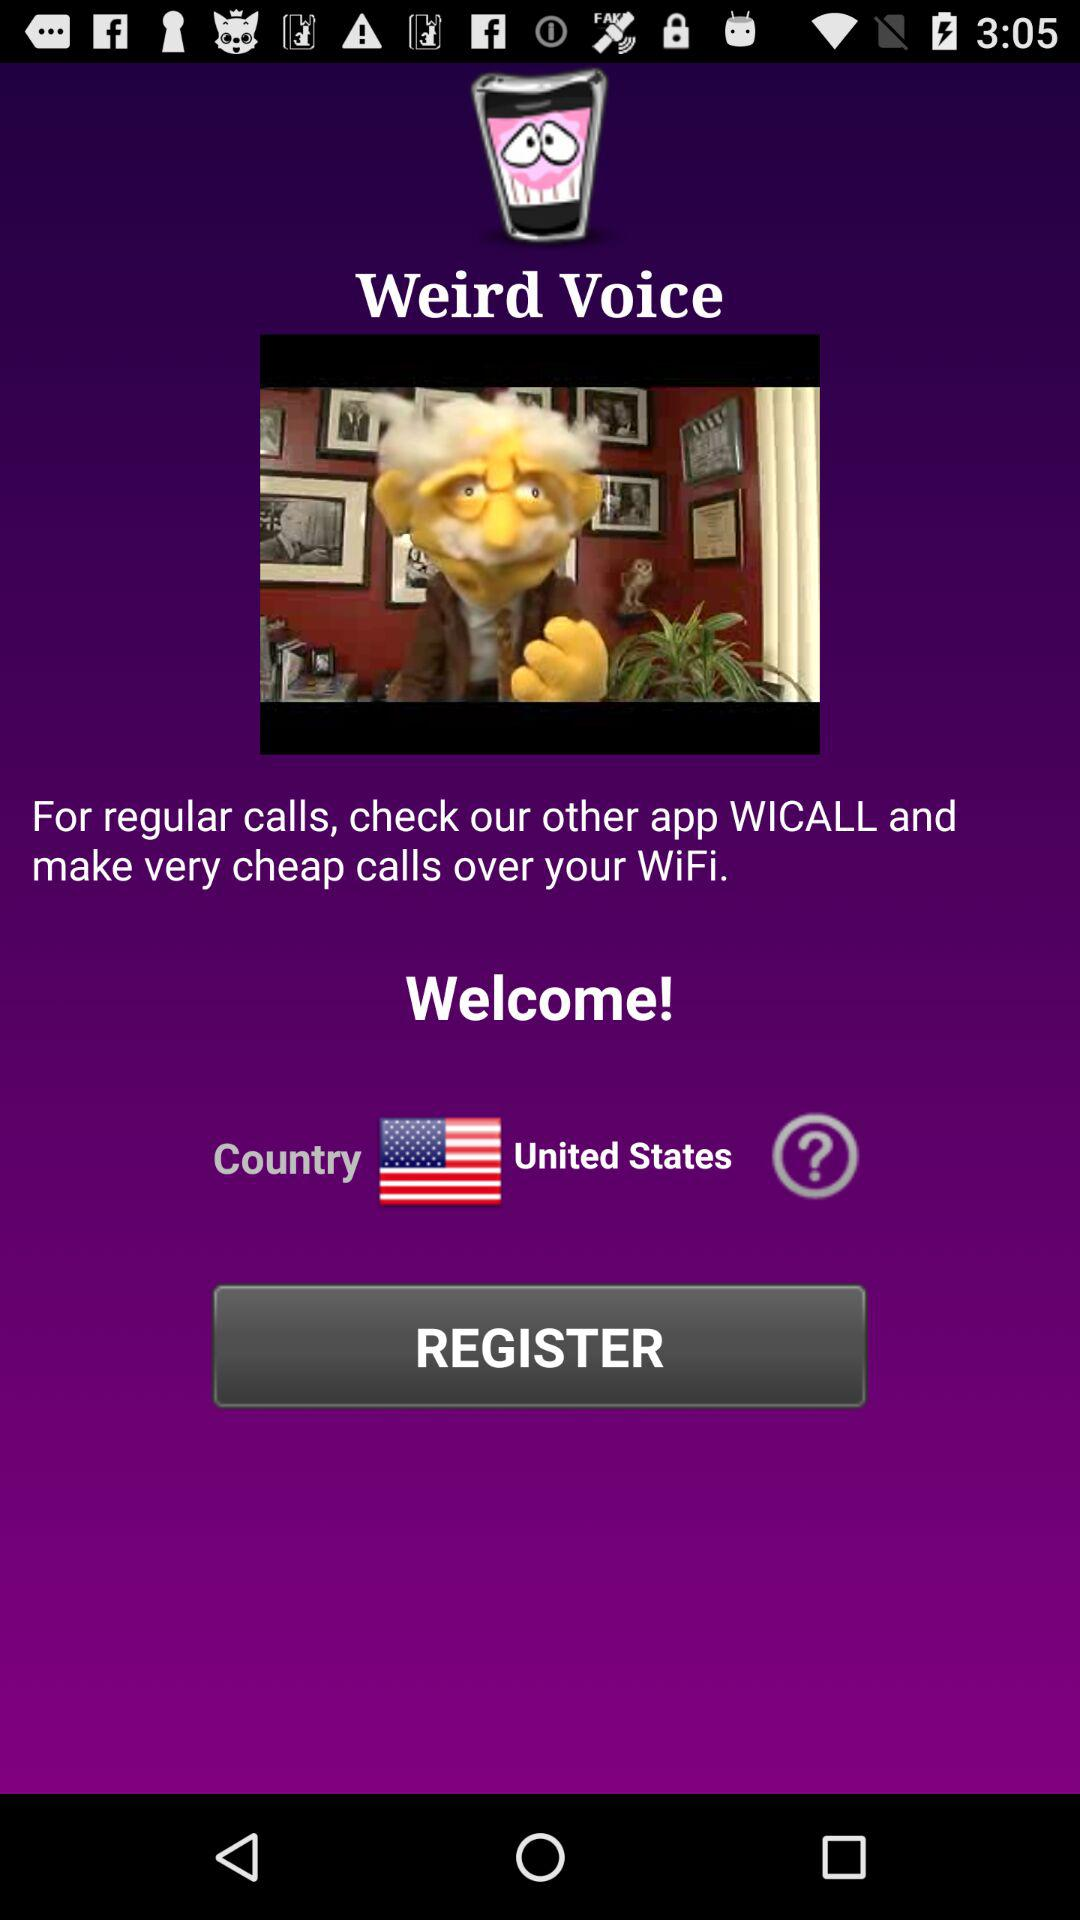What is the application name? The application name is "Weird Voice". 